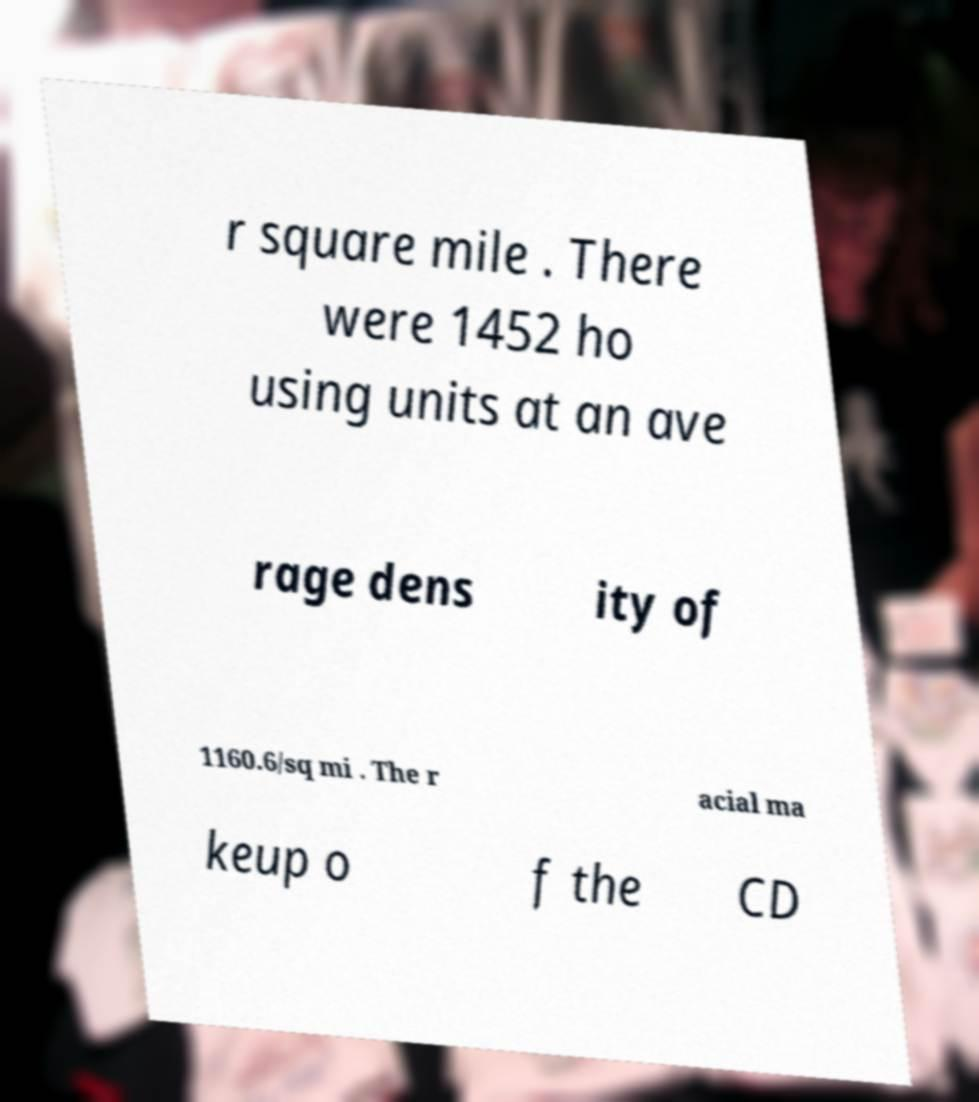Can you read and provide the text displayed in the image?This photo seems to have some interesting text. Can you extract and type it out for me? r square mile . There were 1452 ho using units at an ave rage dens ity of 1160.6/sq mi . The r acial ma keup o f the CD 